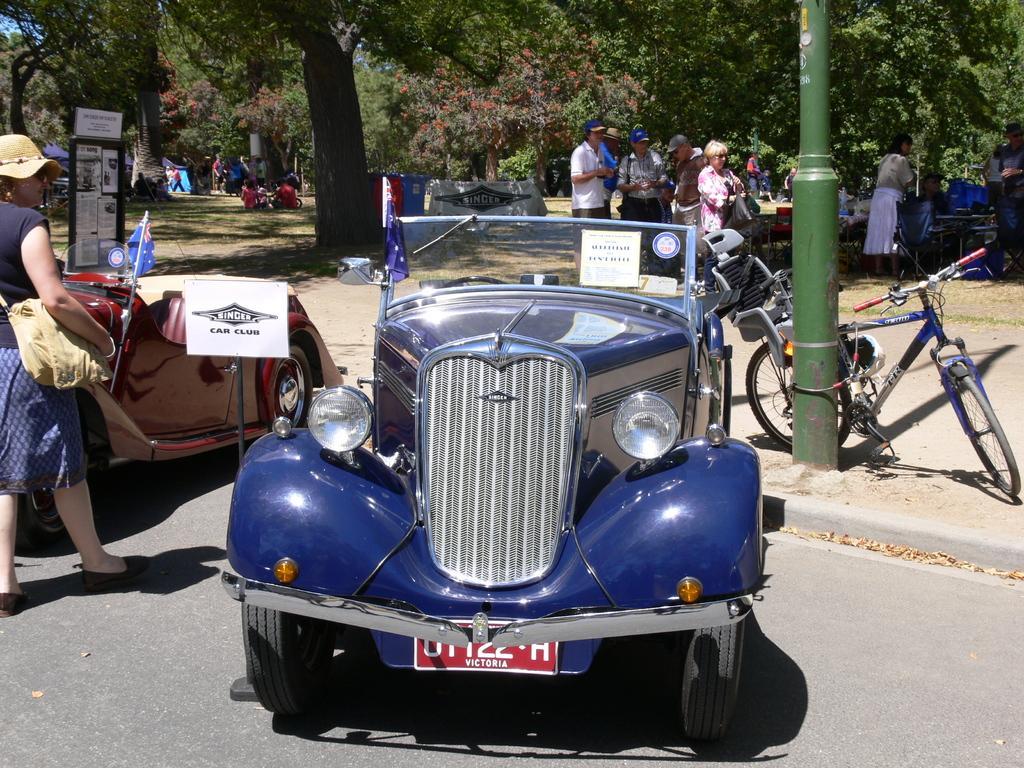Describe this image in one or two sentences. In this image we can a group of motor vehicles parked aside on the road. We can also see the flags. On the left side we can see a board and a woman standing on a road. On the backside we can see a group of people standing, a group of trees, plants and some people sitting on the ground. 